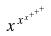<formula> <loc_0><loc_0><loc_500><loc_500>x ^ { x ^ { x ^ { + ^ { + ^ { + } } } } }</formula> 